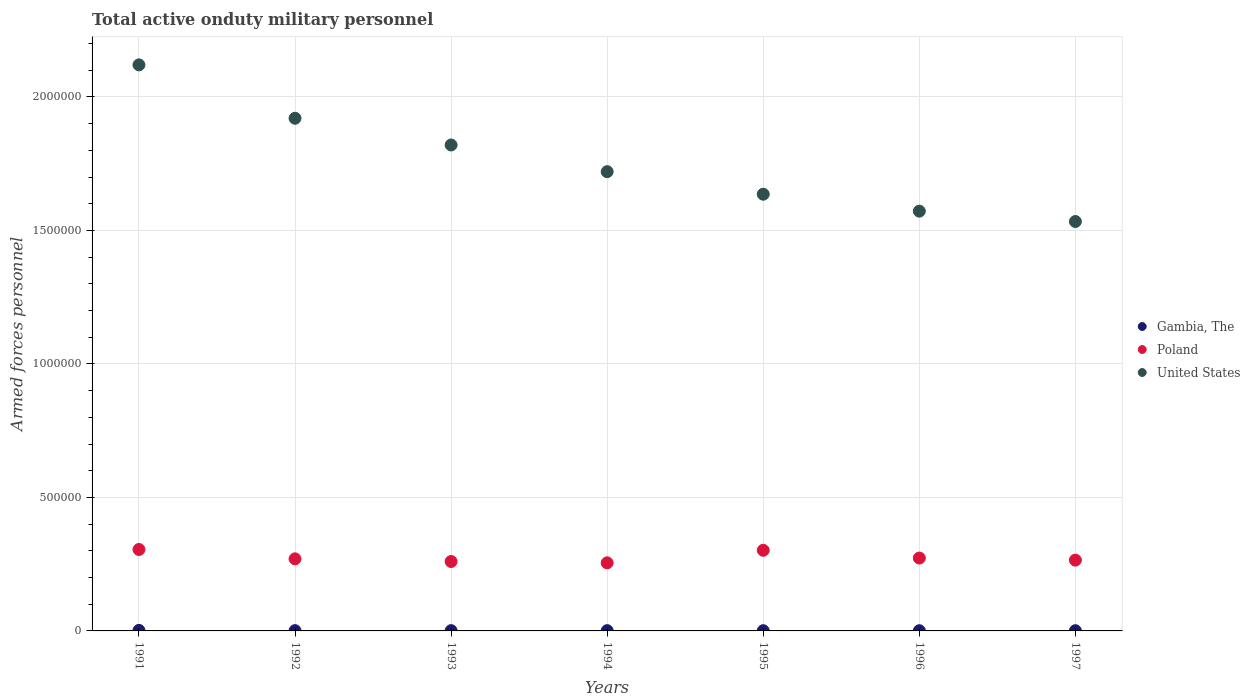How many different coloured dotlines are there?
Your answer should be compact. 3. What is the number of armed forces personnel in United States in 1996?
Ensure brevity in your answer.  1.57e+06. Across all years, what is the maximum number of armed forces personnel in Poland?
Offer a very short reply. 3.05e+05. Across all years, what is the minimum number of armed forces personnel in United States?
Provide a succinct answer. 1.53e+06. In which year was the number of armed forces personnel in United States minimum?
Provide a short and direct response. 1997. What is the total number of armed forces personnel in United States in the graph?
Your answer should be very brief. 1.23e+07. What is the difference between the number of armed forces personnel in United States in 1993 and that in 1995?
Offer a terse response. 1.84e+05. What is the difference between the number of armed forces personnel in Gambia, The in 1995 and the number of armed forces personnel in Poland in 1997?
Your response must be concise. -2.64e+05. What is the average number of armed forces personnel in Poland per year?
Provide a short and direct response. 2.76e+05. In the year 1994, what is the difference between the number of armed forces personnel in Poland and number of armed forces personnel in Gambia, The?
Offer a terse response. 2.54e+05. In how many years, is the number of armed forces personnel in United States greater than 800000?
Offer a very short reply. 7. What is the ratio of the number of armed forces personnel in United States in 1996 to that in 1997?
Offer a very short reply. 1.03. What is the difference between the highest and the second highest number of armed forces personnel in Gambia, The?
Make the answer very short. 1000. What is the difference between the highest and the lowest number of armed forces personnel in Gambia, The?
Give a very brief answer. 1200. In how many years, is the number of armed forces personnel in Poland greater than the average number of armed forces personnel in Poland taken over all years?
Your response must be concise. 2. Is the sum of the number of armed forces personnel in Gambia, The in 1994 and 1996 greater than the maximum number of armed forces personnel in United States across all years?
Your response must be concise. No. Is the number of armed forces personnel in Gambia, The strictly greater than the number of armed forces personnel in Poland over the years?
Ensure brevity in your answer.  No. Is the number of armed forces personnel in Gambia, The strictly less than the number of armed forces personnel in United States over the years?
Offer a terse response. Yes. How many dotlines are there?
Offer a terse response. 3. Does the graph contain any zero values?
Your response must be concise. No. Does the graph contain grids?
Offer a terse response. Yes. Where does the legend appear in the graph?
Keep it short and to the point. Center right. What is the title of the graph?
Provide a succinct answer. Total active onduty military personnel. Does "Chad" appear as one of the legend labels in the graph?
Your response must be concise. No. What is the label or title of the X-axis?
Ensure brevity in your answer.  Years. What is the label or title of the Y-axis?
Offer a very short reply. Armed forces personnel. What is the Armed forces personnel of Poland in 1991?
Your answer should be compact. 3.05e+05. What is the Armed forces personnel of United States in 1991?
Offer a very short reply. 2.12e+06. What is the Armed forces personnel of United States in 1992?
Give a very brief answer. 1.92e+06. What is the Armed forces personnel in United States in 1993?
Your answer should be very brief. 1.82e+06. What is the Armed forces personnel of Poland in 1994?
Make the answer very short. 2.55e+05. What is the Armed forces personnel in United States in 1994?
Provide a short and direct response. 1.72e+06. What is the Armed forces personnel in Gambia, The in 1995?
Give a very brief answer. 800. What is the Armed forces personnel in Poland in 1995?
Ensure brevity in your answer.  3.02e+05. What is the Armed forces personnel of United States in 1995?
Offer a terse response. 1.64e+06. What is the Armed forces personnel of Gambia, The in 1996?
Keep it short and to the point. 800. What is the Armed forces personnel in Poland in 1996?
Provide a short and direct response. 2.73e+05. What is the Armed forces personnel in United States in 1996?
Provide a succinct answer. 1.57e+06. What is the Armed forces personnel of Gambia, The in 1997?
Your answer should be very brief. 800. What is the Armed forces personnel of Poland in 1997?
Your answer should be very brief. 2.65e+05. What is the Armed forces personnel of United States in 1997?
Give a very brief answer. 1.53e+06. Across all years, what is the maximum Armed forces personnel in Poland?
Make the answer very short. 3.05e+05. Across all years, what is the maximum Armed forces personnel in United States?
Give a very brief answer. 2.12e+06. Across all years, what is the minimum Armed forces personnel in Gambia, The?
Your answer should be very brief. 800. Across all years, what is the minimum Armed forces personnel of Poland?
Your answer should be compact. 2.55e+05. Across all years, what is the minimum Armed forces personnel in United States?
Offer a terse response. 1.53e+06. What is the total Armed forces personnel of Gambia, The in the graph?
Offer a very short reply. 7400. What is the total Armed forces personnel in Poland in the graph?
Offer a terse response. 1.93e+06. What is the total Armed forces personnel of United States in the graph?
Keep it short and to the point. 1.23e+07. What is the difference between the Armed forces personnel in Gambia, The in 1991 and that in 1992?
Keep it short and to the point. 1000. What is the difference between the Armed forces personnel in Poland in 1991 and that in 1992?
Your response must be concise. 3.50e+04. What is the difference between the Armed forces personnel of Poland in 1991 and that in 1993?
Make the answer very short. 4.50e+04. What is the difference between the Armed forces personnel of United States in 1991 and that in 1993?
Ensure brevity in your answer.  3.00e+05. What is the difference between the Armed forces personnel in Gambia, The in 1991 and that in 1995?
Offer a terse response. 1200. What is the difference between the Armed forces personnel in Poland in 1991 and that in 1995?
Make the answer very short. 3000. What is the difference between the Armed forces personnel in United States in 1991 and that in 1995?
Your response must be concise. 4.84e+05. What is the difference between the Armed forces personnel in Gambia, The in 1991 and that in 1996?
Your answer should be very brief. 1200. What is the difference between the Armed forces personnel in Poland in 1991 and that in 1996?
Make the answer very short. 3.21e+04. What is the difference between the Armed forces personnel of United States in 1991 and that in 1996?
Your response must be concise. 5.48e+05. What is the difference between the Armed forces personnel of Gambia, The in 1991 and that in 1997?
Offer a very short reply. 1200. What is the difference between the Armed forces personnel in Poland in 1991 and that in 1997?
Your response must be concise. 3.98e+04. What is the difference between the Armed forces personnel of United States in 1991 and that in 1997?
Make the answer very short. 5.87e+05. What is the difference between the Armed forces personnel of Gambia, The in 1992 and that in 1994?
Your answer should be compact. 0. What is the difference between the Armed forces personnel in Poland in 1992 and that in 1994?
Offer a very short reply. 1.50e+04. What is the difference between the Armed forces personnel in United States in 1992 and that in 1994?
Make the answer very short. 2.00e+05. What is the difference between the Armed forces personnel in Gambia, The in 1992 and that in 1995?
Provide a short and direct response. 200. What is the difference between the Armed forces personnel of Poland in 1992 and that in 1995?
Offer a very short reply. -3.20e+04. What is the difference between the Armed forces personnel in United States in 1992 and that in 1995?
Your answer should be very brief. 2.84e+05. What is the difference between the Armed forces personnel of Gambia, The in 1992 and that in 1996?
Your answer should be very brief. 200. What is the difference between the Armed forces personnel of Poland in 1992 and that in 1996?
Make the answer very short. -2900. What is the difference between the Armed forces personnel in United States in 1992 and that in 1996?
Ensure brevity in your answer.  3.48e+05. What is the difference between the Armed forces personnel in Gambia, The in 1992 and that in 1997?
Your answer should be very brief. 200. What is the difference between the Armed forces personnel of Poland in 1992 and that in 1997?
Give a very brief answer. 4850. What is the difference between the Armed forces personnel in United States in 1992 and that in 1997?
Your response must be concise. 3.87e+05. What is the difference between the Armed forces personnel in United States in 1993 and that in 1994?
Provide a short and direct response. 1.00e+05. What is the difference between the Armed forces personnel in Poland in 1993 and that in 1995?
Your answer should be compact. -4.20e+04. What is the difference between the Armed forces personnel in United States in 1993 and that in 1995?
Keep it short and to the point. 1.84e+05. What is the difference between the Armed forces personnel in Gambia, The in 1993 and that in 1996?
Offer a terse response. 200. What is the difference between the Armed forces personnel of Poland in 1993 and that in 1996?
Keep it short and to the point. -1.29e+04. What is the difference between the Armed forces personnel in United States in 1993 and that in 1996?
Keep it short and to the point. 2.48e+05. What is the difference between the Armed forces personnel in Gambia, The in 1993 and that in 1997?
Make the answer very short. 200. What is the difference between the Armed forces personnel in Poland in 1993 and that in 1997?
Your answer should be compact. -5150. What is the difference between the Armed forces personnel of United States in 1993 and that in 1997?
Offer a very short reply. 2.87e+05. What is the difference between the Armed forces personnel of Poland in 1994 and that in 1995?
Your answer should be compact. -4.70e+04. What is the difference between the Armed forces personnel of United States in 1994 and that in 1995?
Provide a succinct answer. 8.44e+04. What is the difference between the Armed forces personnel in Gambia, The in 1994 and that in 1996?
Make the answer very short. 200. What is the difference between the Armed forces personnel in Poland in 1994 and that in 1996?
Your answer should be compact. -1.79e+04. What is the difference between the Armed forces personnel in United States in 1994 and that in 1996?
Your response must be concise. 1.48e+05. What is the difference between the Armed forces personnel of Poland in 1994 and that in 1997?
Give a very brief answer. -1.02e+04. What is the difference between the Armed forces personnel of United States in 1994 and that in 1997?
Offer a very short reply. 1.87e+05. What is the difference between the Armed forces personnel in Poland in 1995 and that in 1996?
Ensure brevity in your answer.  2.91e+04. What is the difference between the Armed forces personnel in United States in 1995 and that in 1996?
Give a very brief answer. 6.35e+04. What is the difference between the Armed forces personnel in Poland in 1995 and that in 1997?
Keep it short and to the point. 3.68e+04. What is the difference between the Armed forces personnel in United States in 1995 and that in 1997?
Provide a short and direct response. 1.02e+05. What is the difference between the Armed forces personnel in Gambia, The in 1996 and that in 1997?
Your answer should be very brief. 0. What is the difference between the Armed forces personnel in Poland in 1996 and that in 1997?
Your answer should be compact. 7750. What is the difference between the Armed forces personnel in United States in 1996 and that in 1997?
Offer a terse response. 3.88e+04. What is the difference between the Armed forces personnel in Gambia, The in 1991 and the Armed forces personnel in Poland in 1992?
Provide a short and direct response. -2.68e+05. What is the difference between the Armed forces personnel of Gambia, The in 1991 and the Armed forces personnel of United States in 1992?
Your answer should be compact. -1.92e+06. What is the difference between the Armed forces personnel of Poland in 1991 and the Armed forces personnel of United States in 1992?
Provide a short and direct response. -1.62e+06. What is the difference between the Armed forces personnel in Gambia, The in 1991 and the Armed forces personnel in Poland in 1993?
Your answer should be compact. -2.58e+05. What is the difference between the Armed forces personnel of Gambia, The in 1991 and the Armed forces personnel of United States in 1993?
Offer a very short reply. -1.82e+06. What is the difference between the Armed forces personnel of Poland in 1991 and the Armed forces personnel of United States in 1993?
Keep it short and to the point. -1.52e+06. What is the difference between the Armed forces personnel of Gambia, The in 1991 and the Armed forces personnel of Poland in 1994?
Your response must be concise. -2.53e+05. What is the difference between the Armed forces personnel of Gambia, The in 1991 and the Armed forces personnel of United States in 1994?
Provide a succinct answer. -1.72e+06. What is the difference between the Armed forces personnel in Poland in 1991 and the Armed forces personnel in United States in 1994?
Your answer should be very brief. -1.42e+06. What is the difference between the Armed forces personnel of Gambia, The in 1991 and the Armed forces personnel of United States in 1995?
Provide a succinct answer. -1.63e+06. What is the difference between the Armed forces personnel of Poland in 1991 and the Armed forces personnel of United States in 1995?
Offer a very short reply. -1.33e+06. What is the difference between the Armed forces personnel in Gambia, The in 1991 and the Armed forces personnel in Poland in 1996?
Provide a short and direct response. -2.71e+05. What is the difference between the Armed forces personnel in Gambia, The in 1991 and the Armed forces personnel in United States in 1996?
Provide a short and direct response. -1.57e+06. What is the difference between the Armed forces personnel of Poland in 1991 and the Armed forces personnel of United States in 1996?
Make the answer very short. -1.27e+06. What is the difference between the Armed forces personnel in Gambia, The in 1991 and the Armed forces personnel in Poland in 1997?
Provide a succinct answer. -2.63e+05. What is the difference between the Armed forces personnel in Gambia, The in 1991 and the Armed forces personnel in United States in 1997?
Your response must be concise. -1.53e+06. What is the difference between the Armed forces personnel of Poland in 1991 and the Armed forces personnel of United States in 1997?
Keep it short and to the point. -1.23e+06. What is the difference between the Armed forces personnel of Gambia, The in 1992 and the Armed forces personnel of Poland in 1993?
Provide a succinct answer. -2.59e+05. What is the difference between the Armed forces personnel in Gambia, The in 1992 and the Armed forces personnel in United States in 1993?
Offer a very short reply. -1.82e+06. What is the difference between the Armed forces personnel in Poland in 1992 and the Armed forces personnel in United States in 1993?
Offer a very short reply. -1.55e+06. What is the difference between the Armed forces personnel of Gambia, The in 1992 and the Armed forces personnel of Poland in 1994?
Keep it short and to the point. -2.54e+05. What is the difference between the Armed forces personnel of Gambia, The in 1992 and the Armed forces personnel of United States in 1994?
Your answer should be very brief. -1.72e+06. What is the difference between the Armed forces personnel of Poland in 1992 and the Armed forces personnel of United States in 1994?
Your answer should be compact. -1.45e+06. What is the difference between the Armed forces personnel of Gambia, The in 1992 and the Armed forces personnel of Poland in 1995?
Keep it short and to the point. -3.01e+05. What is the difference between the Armed forces personnel in Gambia, The in 1992 and the Armed forces personnel in United States in 1995?
Ensure brevity in your answer.  -1.63e+06. What is the difference between the Armed forces personnel of Poland in 1992 and the Armed forces personnel of United States in 1995?
Offer a terse response. -1.37e+06. What is the difference between the Armed forces personnel in Gambia, The in 1992 and the Armed forces personnel in Poland in 1996?
Offer a very short reply. -2.72e+05. What is the difference between the Armed forces personnel in Gambia, The in 1992 and the Armed forces personnel in United States in 1996?
Your answer should be very brief. -1.57e+06. What is the difference between the Armed forces personnel of Poland in 1992 and the Armed forces personnel of United States in 1996?
Offer a very short reply. -1.30e+06. What is the difference between the Armed forces personnel in Gambia, The in 1992 and the Armed forces personnel in Poland in 1997?
Your answer should be compact. -2.64e+05. What is the difference between the Armed forces personnel in Gambia, The in 1992 and the Armed forces personnel in United States in 1997?
Your response must be concise. -1.53e+06. What is the difference between the Armed forces personnel of Poland in 1992 and the Armed forces personnel of United States in 1997?
Ensure brevity in your answer.  -1.26e+06. What is the difference between the Armed forces personnel of Gambia, The in 1993 and the Armed forces personnel of Poland in 1994?
Offer a very short reply. -2.54e+05. What is the difference between the Armed forces personnel of Gambia, The in 1993 and the Armed forces personnel of United States in 1994?
Your answer should be compact. -1.72e+06. What is the difference between the Armed forces personnel of Poland in 1993 and the Armed forces personnel of United States in 1994?
Make the answer very short. -1.46e+06. What is the difference between the Armed forces personnel in Gambia, The in 1993 and the Armed forces personnel in Poland in 1995?
Provide a short and direct response. -3.01e+05. What is the difference between the Armed forces personnel in Gambia, The in 1993 and the Armed forces personnel in United States in 1995?
Provide a short and direct response. -1.63e+06. What is the difference between the Armed forces personnel of Poland in 1993 and the Armed forces personnel of United States in 1995?
Provide a succinct answer. -1.38e+06. What is the difference between the Armed forces personnel of Gambia, The in 1993 and the Armed forces personnel of Poland in 1996?
Provide a short and direct response. -2.72e+05. What is the difference between the Armed forces personnel in Gambia, The in 1993 and the Armed forces personnel in United States in 1996?
Your answer should be compact. -1.57e+06. What is the difference between the Armed forces personnel in Poland in 1993 and the Armed forces personnel in United States in 1996?
Your answer should be compact. -1.31e+06. What is the difference between the Armed forces personnel in Gambia, The in 1993 and the Armed forces personnel in Poland in 1997?
Make the answer very short. -2.64e+05. What is the difference between the Armed forces personnel of Gambia, The in 1993 and the Armed forces personnel of United States in 1997?
Provide a succinct answer. -1.53e+06. What is the difference between the Armed forces personnel of Poland in 1993 and the Armed forces personnel of United States in 1997?
Offer a very short reply. -1.27e+06. What is the difference between the Armed forces personnel in Gambia, The in 1994 and the Armed forces personnel in Poland in 1995?
Make the answer very short. -3.01e+05. What is the difference between the Armed forces personnel of Gambia, The in 1994 and the Armed forces personnel of United States in 1995?
Keep it short and to the point. -1.63e+06. What is the difference between the Armed forces personnel of Poland in 1994 and the Armed forces personnel of United States in 1995?
Ensure brevity in your answer.  -1.38e+06. What is the difference between the Armed forces personnel of Gambia, The in 1994 and the Armed forces personnel of Poland in 1996?
Give a very brief answer. -2.72e+05. What is the difference between the Armed forces personnel in Gambia, The in 1994 and the Armed forces personnel in United States in 1996?
Keep it short and to the point. -1.57e+06. What is the difference between the Armed forces personnel in Poland in 1994 and the Armed forces personnel in United States in 1996?
Your response must be concise. -1.32e+06. What is the difference between the Armed forces personnel of Gambia, The in 1994 and the Armed forces personnel of Poland in 1997?
Offer a very short reply. -2.64e+05. What is the difference between the Armed forces personnel in Gambia, The in 1994 and the Armed forces personnel in United States in 1997?
Make the answer very short. -1.53e+06. What is the difference between the Armed forces personnel of Poland in 1994 and the Armed forces personnel of United States in 1997?
Make the answer very short. -1.28e+06. What is the difference between the Armed forces personnel of Gambia, The in 1995 and the Armed forces personnel of Poland in 1996?
Your answer should be very brief. -2.72e+05. What is the difference between the Armed forces personnel of Gambia, The in 1995 and the Armed forces personnel of United States in 1996?
Provide a succinct answer. -1.57e+06. What is the difference between the Armed forces personnel in Poland in 1995 and the Armed forces personnel in United States in 1996?
Offer a terse response. -1.27e+06. What is the difference between the Armed forces personnel in Gambia, The in 1995 and the Armed forces personnel in Poland in 1997?
Ensure brevity in your answer.  -2.64e+05. What is the difference between the Armed forces personnel in Gambia, The in 1995 and the Armed forces personnel in United States in 1997?
Your answer should be very brief. -1.53e+06. What is the difference between the Armed forces personnel in Poland in 1995 and the Armed forces personnel in United States in 1997?
Your answer should be compact. -1.23e+06. What is the difference between the Armed forces personnel in Gambia, The in 1996 and the Armed forces personnel in Poland in 1997?
Keep it short and to the point. -2.64e+05. What is the difference between the Armed forces personnel of Gambia, The in 1996 and the Armed forces personnel of United States in 1997?
Ensure brevity in your answer.  -1.53e+06. What is the difference between the Armed forces personnel of Poland in 1996 and the Armed forces personnel of United States in 1997?
Give a very brief answer. -1.26e+06. What is the average Armed forces personnel of Gambia, The per year?
Provide a succinct answer. 1057.14. What is the average Armed forces personnel of Poland per year?
Provide a succinct answer. 2.76e+05. What is the average Armed forces personnel in United States per year?
Ensure brevity in your answer.  1.76e+06. In the year 1991, what is the difference between the Armed forces personnel in Gambia, The and Armed forces personnel in Poland?
Ensure brevity in your answer.  -3.03e+05. In the year 1991, what is the difference between the Armed forces personnel of Gambia, The and Armed forces personnel of United States?
Provide a succinct answer. -2.12e+06. In the year 1991, what is the difference between the Armed forces personnel of Poland and Armed forces personnel of United States?
Your answer should be compact. -1.82e+06. In the year 1992, what is the difference between the Armed forces personnel in Gambia, The and Armed forces personnel in Poland?
Keep it short and to the point. -2.69e+05. In the year 1992, what is the difference between the Armed forces personnel in Gambia, The and Armed forces personnel in United States?
Offer a terse response. -1.92e+06. In the year 1992, what is the difference between the Armed forces personnel in Poland and Armed forces personnel in United States?
Give a very brief answer. -1.65e+06. In the year 1993, what is the difference between the Armed forces personnel in Gambia, The and Armed forces personnel in Poland?
Keep it short and to the point. -2.59e+05. In the year 1993, what is the difference between the Armed forces personnel of Gambia, The and Armed forces personnel of United States?
Give a very brief answer. -1.82e+06. In the year 1993, what is the difference between the Armed forces personnel in Poland and Armed forces personnel in United States?
Offer a terse response. -1.56e+06. In the year 1994, what is the difference between the Armed forces personnel in Gambia, The and Armed forces personnel in Poland?
Provide a short and direct response. -2.54e+05. In the year 1994, what is the difference between the Armed forces personnel in Gambia, The and Armed forces personnel in United States?
Give a very brief answer. -1.72e+06. In the year 1994, what is the difference between the Armed forces personnel in Poland and Armed forces personnel in United States?
Keep it short and to the point. -1.46e+06. In the year 1995, what is the difference between the Armed forces personnel in Gambia, The and Armed forces personnel in Poland?
Ensure brevity in your answer.  -3.01e+05. In the year 1995, what is the difference between the Armed forces personnel of Gambia, The and Armed forces personnel of United States?
Offer a terse response. -1.63e+06. In the year 1995, what is the difference between the Armed forces personnel of Poland and Armed forces personnel of United States?
Your response must be concise. -1.33e+06. In the year 1996, what is the difference between the Armed forces personnel of Gambia, The and Armed forces personnel of Poland?
Your answer should be compact. -2.72e+05. In the year 1996, what is the difference between the Armed forces personnel of Gambia, The and Armed forces personnel of United States?
Provide a succinct answer. -1.57e+06. In the year 1996, what is the difference between the Armed forces personnel in Poland and Armed forces personnel in United States?
Make the answer very short. -1.30e+06. In the year 1997, what is the difference between the Armed forces personnel of Gambia, The and Armed forces personnel of Poland?
Offer a terse response. -2.64e+05. In the year 1997, what is the difference between the Armed forces personnel of Gambia, The and Armed forces personnel of United States?
Your answer should be very brief. -1.53e+06. In the year 1997, what is the difference between the Armed forces personnel of Poland and Armed forces personnel of United States?
Ensure brevity in your answer.  -1.27e+06. What is the ratio of the Armed forces personnel in Gambia, The in 1991 to that in 1992?
Provide a succinct answer. 2. What is the ratio of the Armed forces personnel in Poland in 1991 to that in 1992?
Ensure brevity in your answer.  1.13. What is the ratio of the Armed forces personnel in United States in 1991 to that in 1992?
Provide a succinct answer. 1.1. What is the ratio of the Armed forces personnel in Poland in 1991 to that in 1993?
Provide a short and direct response. 1.17. What is the ratio of the Armed forces personnel of United States in 1991 to that in 1993?
Make the answer very short. 1.16. What is the ratio of the Armed forces personnel of Gambia, The in 1991 to that in 1994?
Give a very brief answer. 2. What is the ratio of the Armed forces personnel in Poland in 1991 to that in 1994?
Your answer should be very brief. 1.2. What is the ratio of the Armed forces personnel of United States in 1991 to that in 1994?
Provide a short and direct response. 1.23. What is the ratio of the Armed forces personnel in Poland in 1991 to that in 1995?
Keep it short and to the point. 1.01. What is the ratio of the Armed forces personnel in United States in 1991 to that in 1995?
Provide a short and direct response. 1.3. What is the ratio of the Armed forces personnel of Poland in 1991 to that in 1996?
Ensure brevity in your answer.  1.12. What is the ratio of the Armed forces personnel in United States in 1991 to that in 1996?
Offer a terse response. 1.35. What is the ratio of the Armed forces personnel of Gambia, The in 1991 to that in 1997?
Make the answer very short. 2.5. What is the ratio of the Armed forces personnel in Poland in 1991 to that in 1997?
Make the answer very short. 1.15. What is the ratio of the Armed forces personnel of United States in 1991 to that in 1997?
Ensure brevity in your answer.  1.38. What is the ratio of the Armed forces personnel of Poland in 1992 to that in 1993?
Make the answer very short. 1.04. What is the ratio of the Armed forces personnel in United States in 1992 to that in 1993?
Offer a terse response. 1.05. What is the ratio of the Armed forces personnel in Poland in 1992 to that in 1994?
Keep it short and to the point. 1.06. What is the ratio of the Armed forces personnel of United States in 1992 to that in 1994?
Ensure brevity in your answer.  1.12. What is the ratio of the Armed forces personnel of Poland in 1992 to that in 1995?
Your response must be concise. 0.89. What is the ratio of the Armed forces personnel in United States in 1992 to that in 1995?
Offer a very short reply. 1.17. What is the ratio of the Armed forces personnel of Gambia, The in 1992 to that in 1996?
Keep it short and to the point. 1.25. What is the ratio of the Armed forces personnel of United States in 1992 to that in 1996?
Offer a terse response. 1.22. What is the ratio of the Armed forces personnel in Poland in 1992 to that in 1997?
Your answer should be compact. 1.02. What is the ratio of the Armed forces personnel of United States in 1992 to that in 1997?
Keep it short and to the point. 1.25. What is the ratio of the Armed forces personnel of Poland in 1993 to that in 1994?
Keep it short and to the point. 1.02. What is the ratio of the Armed forces personnel of United States in 1993 to that in 1994?
Your response must be concise. 1.06. What is the ratio of the Armed forces personnel of Gambia, The in 1993 to that in 1995?
Make the answer very short. 1.25. What is the ratio of the Armed forces personnel of Poland in 1993 to that in 1995?
Provide a short and direct response. 0.86. What is the ratio of the Armed forces personnel of United States in 1993 to that in 1995?
Make the answer very short. 1.11. What is the ratio of the Armed forces personnel of Gambia, The in 1993 to that in 1996?
Give a very brief answer. 1.25. What is the ratio of the Armed forces personnel in Poland in 1993 to that in 1996?
Offer a terse response. 0.95. What is the ratio of the Armed forces personnel in United States in 1993 to that in 1996?
Provide a short and direct response. 1.16. What is the ratio of the Armed forces personnel of Gambia, The in 1993 to that in 1997?
Your response must be concise. 1.25. What is the ratio of the Armed forces personnel of Poland in 1993 to that in 1997?
Make the answer very short. 0.98. What is the ratio of the Armed forces personnel in United States in 1993 to that in 1997?
Provide a short and direct response. 1.19. What is the ratio of the Armed forces personnel of Gambia, The in 1994 to that in 1995?
Keep it short and to the point. 1.25. What is the ratio of the Armed forces personnel of Poland in 1994 to that in 1995?
Ensure brevity in your answer.  0.84. What is the ratio of the Armed forces personnel of United States in 1994 to that in 1995?
Your answer should be compact. 1.05. What is the ratio of the Armed forces personnel of Gambia, The in 1994 to that in 1996?
Your answer should be compact. 1.25. What is the ratio of the Armed forces personnel of Poland in 1994 to that in 1996?
Provide a short and direct response. 0.93. What is the ratio of the Armed forces personnel in United States in 1994 to that in 1996?
Provide a short and direct response. 1.09. What is the ratio of the Armed forces personnel of Gambia, The in 1994 to that in 1997?
Your response must be concise. 1.25. What is the ratio of the Armed forces personnel of Poland in 1994 to that in 1997?
Keep it short and to the point. 0.96. What is the ratio of the Armed forces personnel of United States in 1994 to that in 1997?
Give a very brief answer. 1.12. What is the ratio of the Armed forces personnel of Gambia, The in 1995 to that in 1996?
Make the answer very short. 1. What is the ratio of the Armed forces personnel of Poland in 1995 to that in 1996?
Provide a short and direct response. 1.11. What is the ratio of the Armed forces personnel in United States in 1995 to that in 1996?
Provide a succinct answer. 1.04. What is the ratio of the Armed forces personnel of Poland in 1995 to that in 1997?
Make the answer very short. 1.14. What is the ratio of the Armed forces personnel in United States in 1995 to that in 1997?
Your response must be concise. 1.07. What is the ratio of the Armed forces personnel in Poland in 1996 to that in 1997?
Make the answer very short. 1.03. What is the ratio of the Armed forces personnel in United States in 1996 to that in 1997?
Offer a very short reply. 1.03. What is the difference between the highest and the second highest Armed forces personnel of Gambia, The?
Provide a short and direct response. 1000. What is the difference between the highest and the second highest Armed forces personnel in Poland?
Give a very brief answer. 3000. What is the difference between the highest and the second highest Armed forces personnel of United States?
Keep it short and to the point. 2.00e+05. What is the difference between the highest and the lowest Armed forces personnel of Gambia, The?
Your response must be concise. 1200. What is the difference between the highest and the lowest Armed forces personnel of Poland?
Provide a short and direct response. 5.00e+04. What is the difference between the highest and the lowest Armed forces personnel in United States?
Offer a terse response. 5.87e+05. 